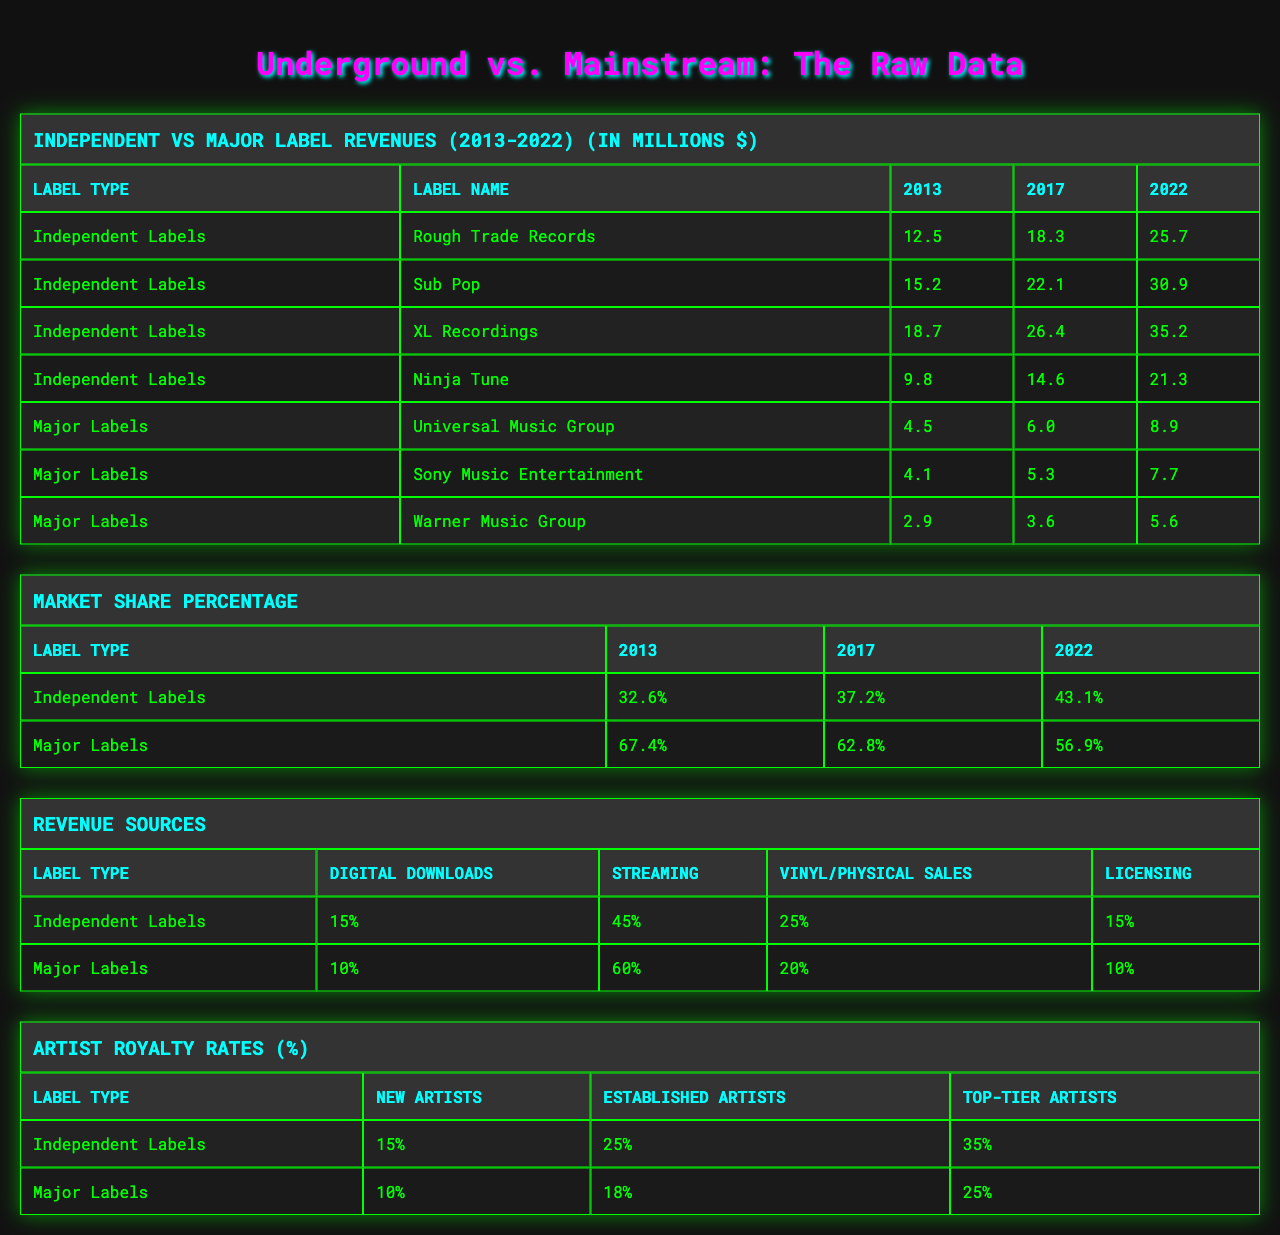What were the revenues of Rough Trade Records in 2022? The table lists the revenues for Rough Trade Records in 2022 as 25.7 million dollars.
Answer: 25.7 million dollars Which independent label had the highest revenue growth from 2013 to 2022? To find the growth, calculate the difference for each label: Rough Trade: (25.7 - 12.5), Sub Pop: (30.9 - 15.2), XL Recordings: (35.2 - 18.7), Ninja Tune: (21.3 - 9.8). The highest growth is for XL Recordings: 16.5 million dollars.
Answer: XL Recordings What was the market share percentage of major labels in 2022? The market share percentage table indicates that major labels held 56.9% in 2022.
Answer: 56.9% Did independent labels surpass major labels in market share by 2022? In 2022, independent labels had a market share of 43.1%, while major labels had 56.9%. Thus, independent labels did not surpass major labels.
Answer: No What was the average revenue for major labels in 2022? The revenues of major labels in 2022 are: Universal Music Group (8.9), Sony Music Entertainment (7.7), and Warner Music Group (5.6). The average is (8.9 + 7.7 + 5.6) / 3 = 7.4 million dollars.
Answer: 7.4 million dollars Which type of revenue source contributes the most percentage to major labels? The revenue sources for major labels indicate streaming contributes 60%, higher than other sources (10% downloads, 20% physical sales, 10% licensing).
Answer: Streaming What is the difference in artist royalty rates for established artists between independent and major labels? The table shows independent labels pay 25% while major labels pay 18% for established artists. The difference is 25% - 18% = 7%.
Answer: 7% What is the total revenue for all independent labels in 2022? The revenues for independent labels in 2022 are: Rough Trade (25.7), Sub Pop (30.9), XL Recordings (35.2), Ninja Tune (21.3). The total is 25.7 + 30.9 + 35.2 + 21.3 = 113.1 million dollars.
Answer: 113.1 million dollars Which independent label had the lowest revenue in 2013? The table shows revenues for 2013: Rough Trade (12.5), Sub Pop (15.2), XL Recordings (18.7), Ninja Tune (9.8). The lowest revenue is from Ninja Tune.
Answer: Ninja Tune Is the trend for independent labels' market share increasing or decreasing from 2013 to 2022? Examining the market share percentages, independent labels increased from 32.6% in 2013 to 43.1% in 2022, indicating an increasing trend.
Answer: Increasing 